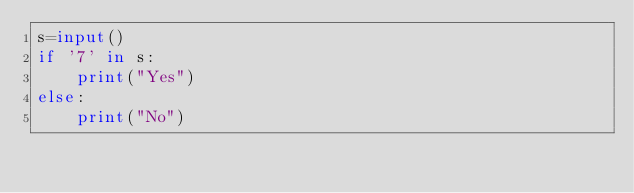<code> <loc_0><loc_0><loc_500><loc_500><_Python_>s=input()
if '7' in s:
    print("Yes")
else:
    print("No")</code> 